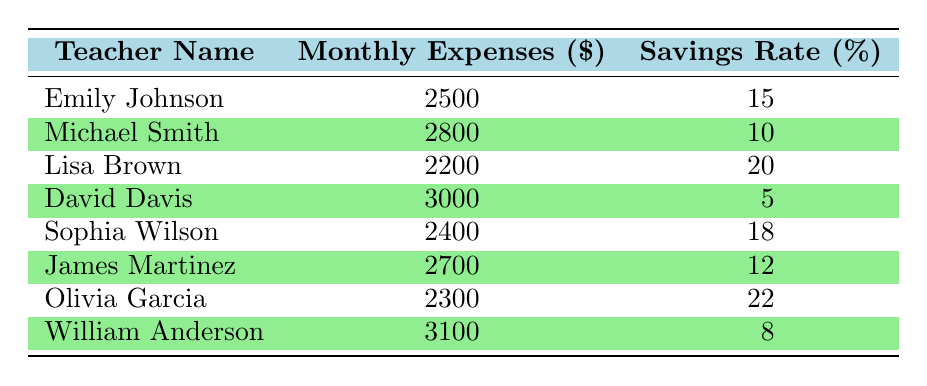What are the monthly expenses of Lisa Brown? The table indicates that Lisa Brown has monthly expenses listed in the second column next to her name. The amount is 2200.
Answer: 2200 Is there any teacher with a savings rate of 22%? By checking the list of savings rates in the table, I find that Olivia Garcia has a savings rate of 22%.
Answer: Yes Which teacher has the lowest savings rate? Looking at the savings rates in the last column, David Davis's rate is the lowest at 5%.
Answer: David Davis What is the average monthly expense of all the teachers? To calculate the average, add all the monthly expenses: 2500 + 2800 + 2200 + 3000 + 2400 + 2700 + 2300 + 3100 = 22600. Next, divide by 8 (the number of teachers): 22600 / 8 = 2825.
Answer: 2825 How does the savings rate compare between those with expenses below 2500 and above 2500? First, identify the groups. Emily Johnson, Lisa Brown, and Olivia Garcia have expenses below 2500 (15%, 20%, 22%) and average to (15+20+22)/3 = 19%. The others (Michael Smith, David Davis, Sophia Wilson, James Martinez, and William Anderson) have expenses above 2500 (10%, 5%, 18%, 12%, 8%) and average to (10+5+18+12+8)/5 = 10.6%. The results show that the first group has a higher savings rate than the second.
Answer: Yes, the first group has a higher savings rate Is there any teacher with monthly expenses of 3100? Checking through the list of monthly expenses, I see that William Anderson has expenses listed at 3100.
Answer: Yes 